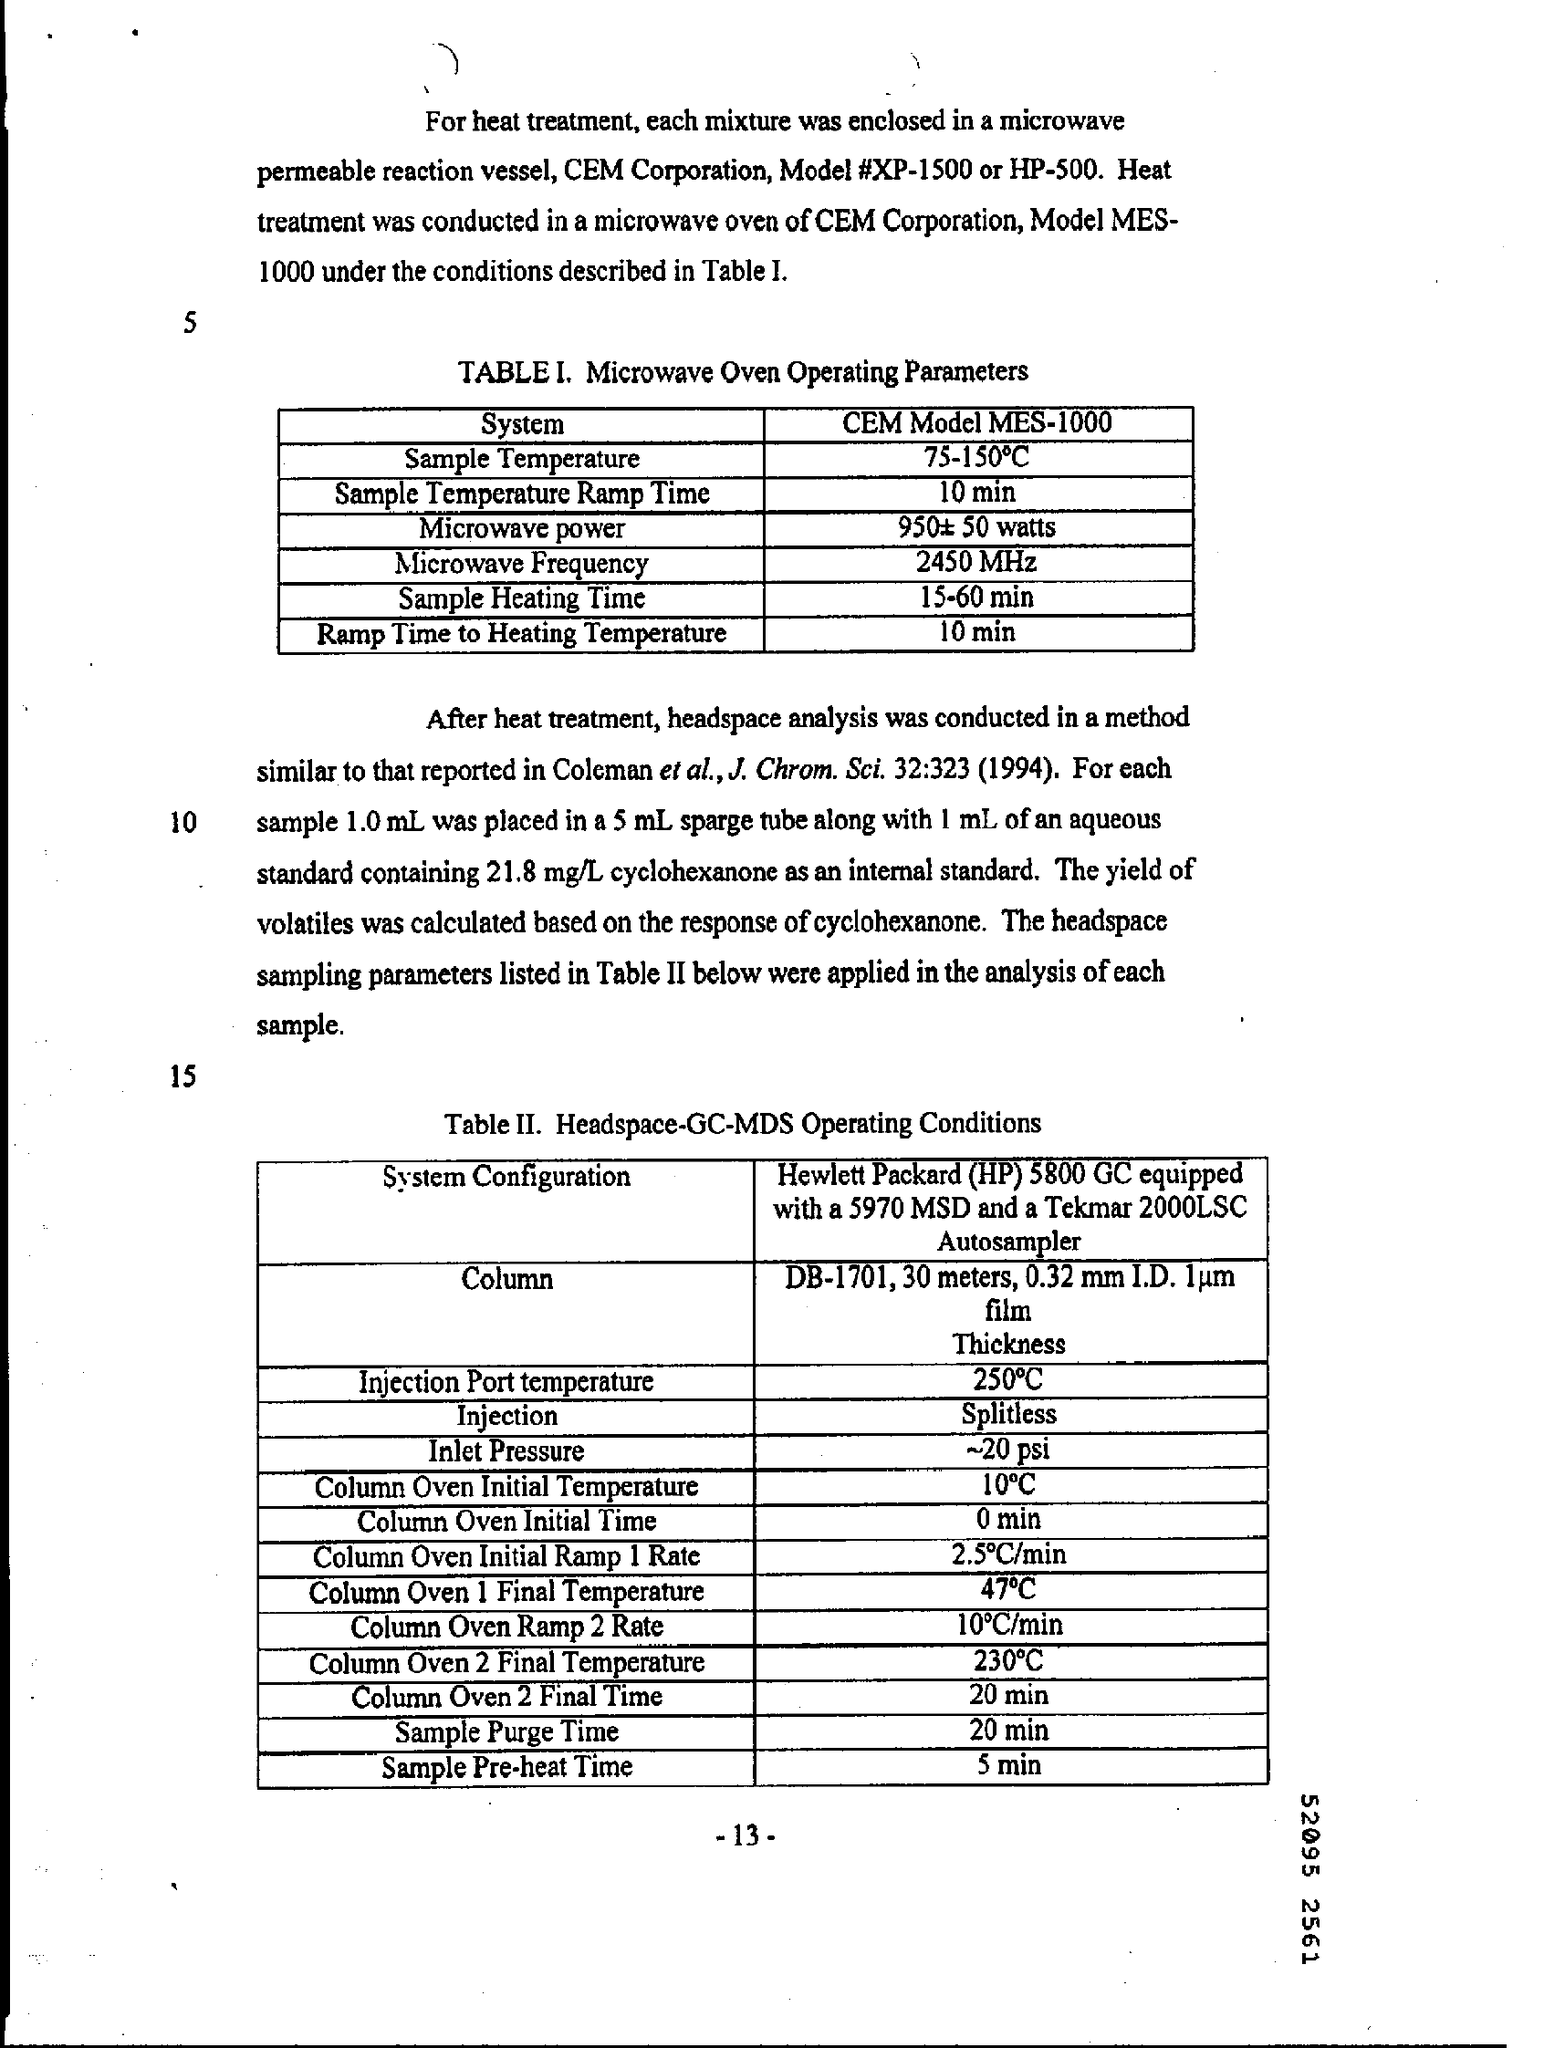What did the table 1 refers to ?
Give a very brief answer. Microwave oven operating parameters. What is the inlet pressure ?
Provide a short and direct response. ~20 psi. 